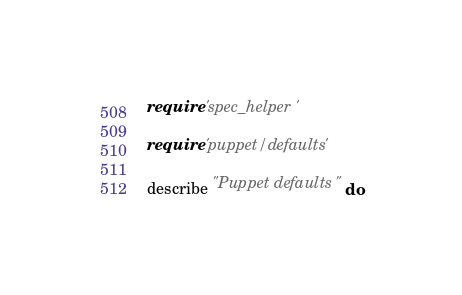<code> <loc_0><loc_0><loc_500><loc_500><_Ruby_>require 'spec_helper'

require 'puppet/defaults'

describe "Puppet defaults" do
</code> 